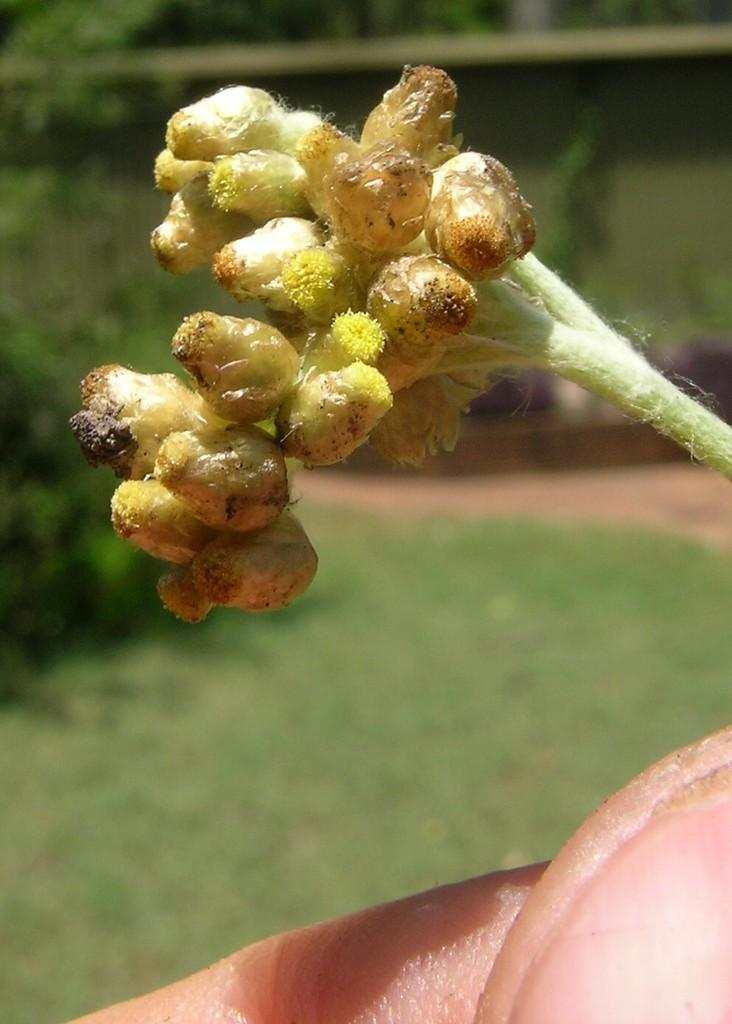What is the human in the image holding? The human is holding a plant in the image. What type of vegetation can be seen in the image? There is grass visible in the image, and other plants can be seen in the background. What type of lipstick is the human wearing in the image? There is no lipstick or any indication of makeup on the human in the image. 